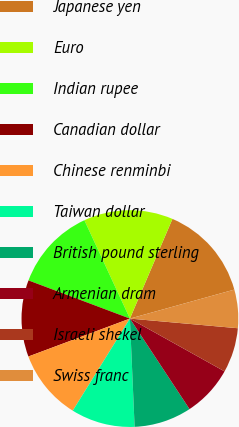Convert chart to OTSL. <chart><loc_0><loc_0><loc_500><loc_500><pie_chart><fcel>Japanese yen<fcel>Euro<fcel>Indian rupee<fcel>Canadian dollar<fcel>Chinese renminbi<fcel>Taiwan dollar<fcel>British pound sterling<fcel>Armenian dram<fcel>Israeli shekel<fcel>Swiss franc<nl><fcel>14.27%<fcel>13.32%<fcel>12.37%<fcel>11.42%<fcel>10.47%<fcel>9.53%<fcel>8.58%<fcel>7.63%<fcel>6.68%<fcel>5.73%<nl></chart> 